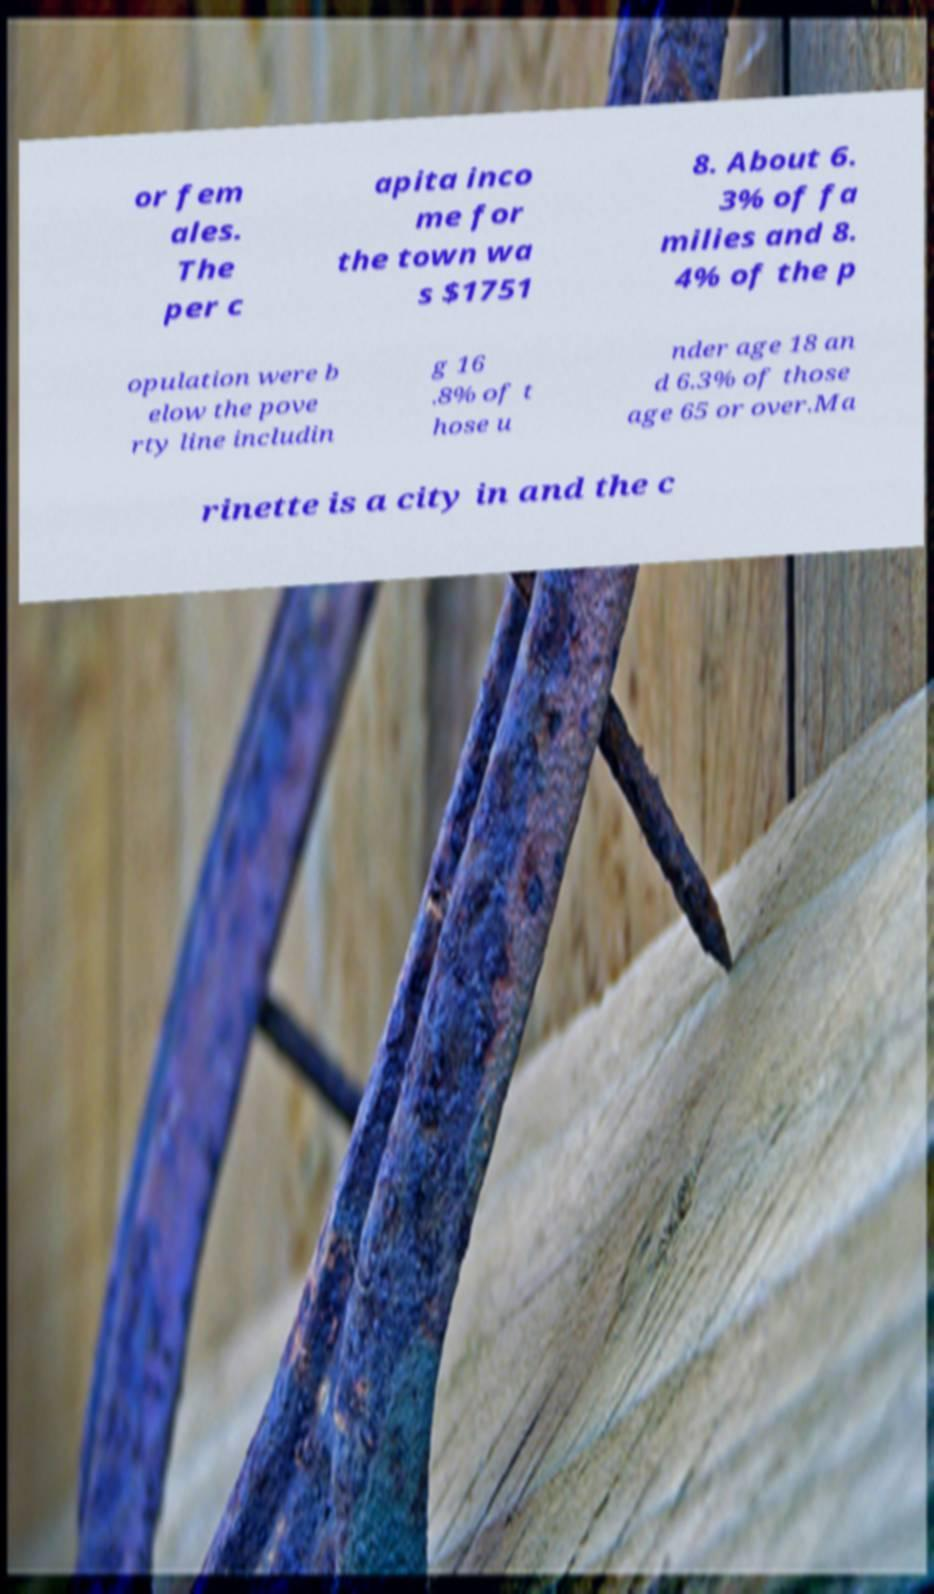For documentation purposes, I need the text within this image transcribed. Could you provide that? or fem ales. The per c apita inco me for the town wa s $1751 8. About 6. 3% of fa milies and 8. 4% of the p opulation were b elow the pove rty line includin g 16 .8% of t hose u nder age 18 an d 6.3% of those age 65 or over.Ma rinette is a city in and the c 